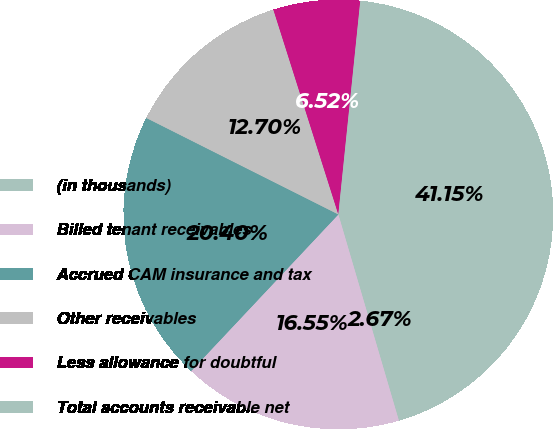Convert chart. <chart><loc_0><loc_0><loc_500><loc_500><pie_chart><fcel>(in thousands)<fcel>Billed tenant receivables<fcel>Accrued CAM insurance and tax<fcel>Other receivables<fcel>Less allowance for doubtful<fcel>Total accounts receivable net<nl><fcel>2.67%<fcel>16.55%<fcel>20.4%<fcel>12.7%<fcel>6.52%<fcel>41.15%<nl></chart> 